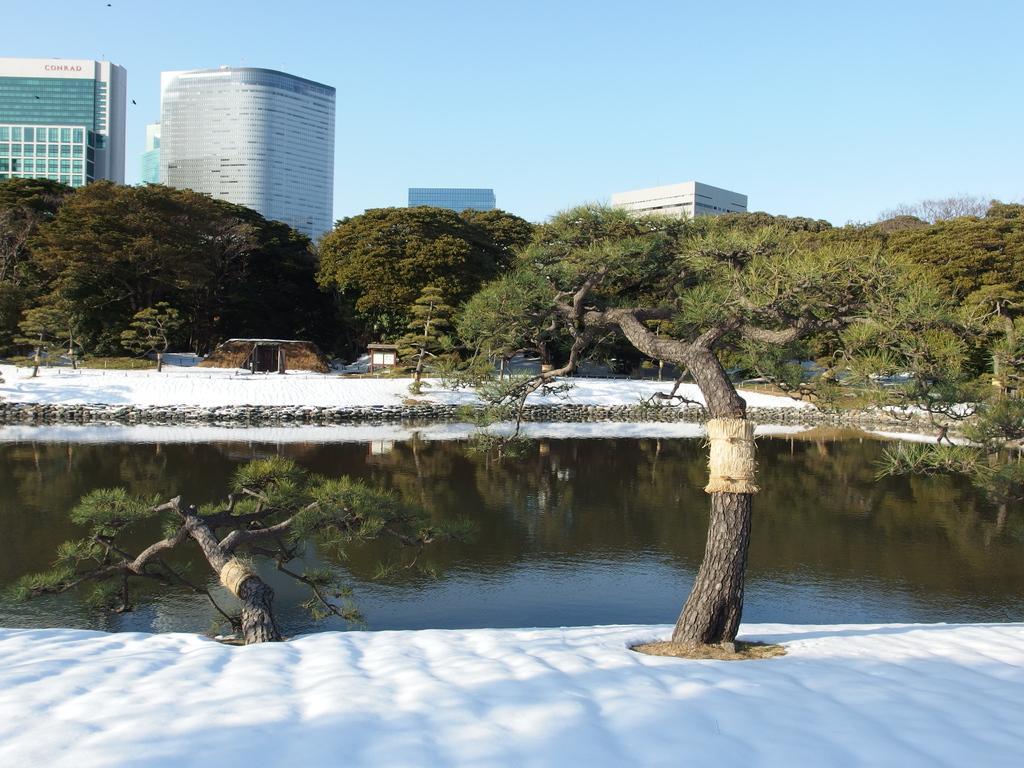In one or two sentences, can you explain what this image depicts? Here we can see two trees and snow. In the background there is water,snow,buildings,trees,glass doors,windows and sky. 